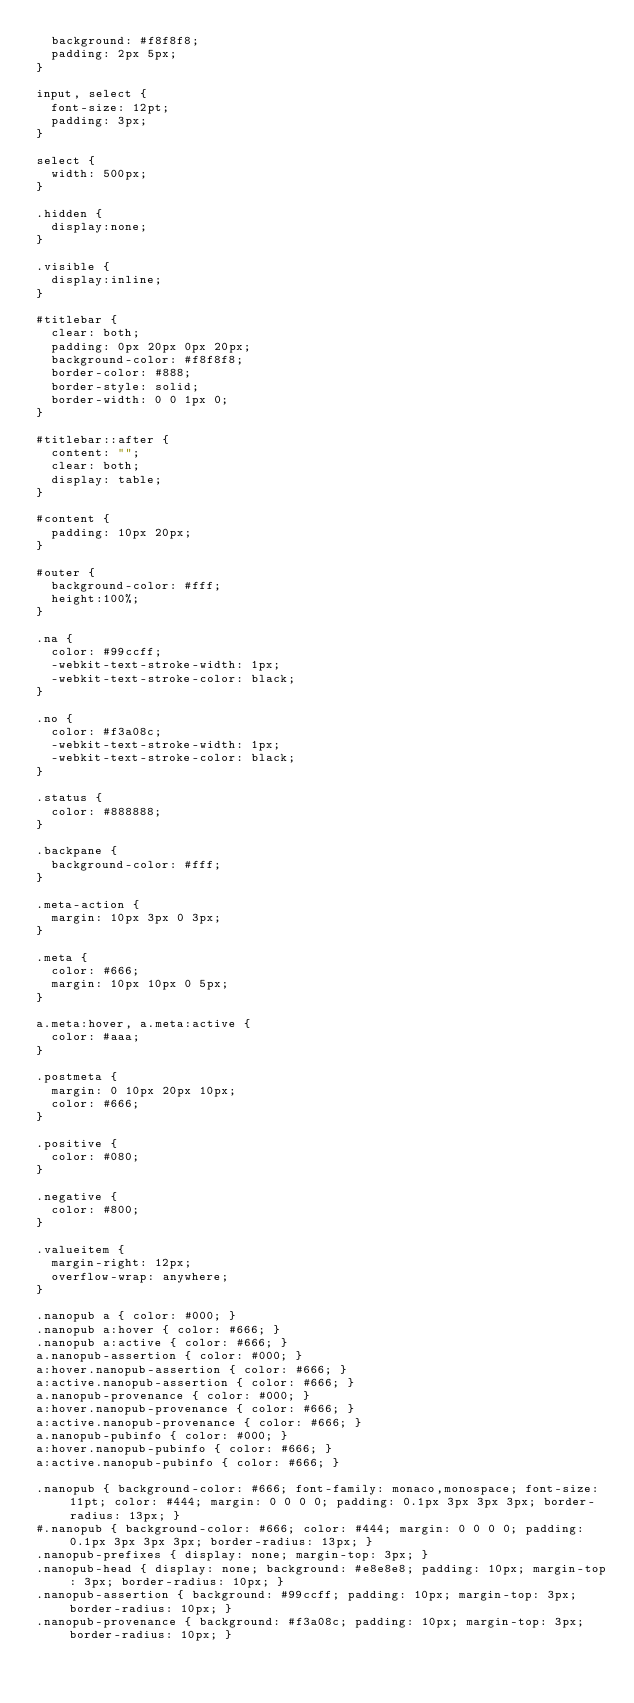<code> <loc_0><loc_0><loc_500><loc_500><_CSS_>  background: #f8f8f8;
  padding: 2px 5px;
}

input, select {
  font-size: 12pt;
  padding: 3px;
}

select {
  width: 500px;
}

.hidden {
	display:none;
}

.visible {
	display:inline;
}

#titlebar {
	clear: both;
	padding: 0px 20px 0px 20px;
	background-color: #f8f8f8;
	border-color: #888;
	border-style: solid;
	border-width: 0 0 1px 0;
}

#titlebar::after {
  content: "";
  clear: both;
  display: table;
}

#content {
	padding: 10px 20px;
}

#outer {
	background-color: #fff;
	height:100%;
}

.na {
  color: #99ccff;
  -webkit-text-stroke-width: 1px;
  -webkit-text-stroke-color: black;
}

.no {
  color: #f3a08c;
  -webkit-text-stroke-width: 1px;
  -webkit-text-stroke-color: black;
}

.status {
  color: #888888;
}

.backpane {
	background-color: #fff;
}

.meta-action {
	margin: 10px 3px 0 3px;
}

.meta {
	color: #666;
	margin: 10px 10px 0 5px;
}

a.meta:hover, a.meta:active {
	color: #aaa;
}

.postmeta {
	margin: 0 10px 20px 10px;
	color: #666;
}

.positive {
	color: #080;
}

.negative {
	color: #800;
}

.valueitem {
	margin-right: 12px;
	overflow-wrap: anywhere;
}

.nanopub a { color: #000; }
.nanopub a:hover { color: #666; }
.nanopub a:active { color: #666; }
a.nanopub-assertion { color: #000; }
a:hover.nanopub-assertion { color: #666; }
a:active.nanopub-assertion { color: #666; }
a.nanopub-provenance { color: #000; }
a:hover.nanopub-provenance { color: #666; }
a:active.nanopub-provenance { color: #666; }
a.nanopub-pubinfo { color: #000; }
a:hover.nanopub-pubinfo { color: #666; }
a:active.nanopub-pubinfo { color: #666; }

.nanopub { background-color: #666; font-family: monaco,monospace; font-size: 11pt; color: #444; margin: 0 0 0 0; padding: 0.1px 3px 3px 3px; border-radius: 13px; }
#.nanopub { background-color: #666; color: #444; margin: 0 0 0 0; padding: 0.1px 3px 3px 3px; border-radius: 13px; }
.nanopub-prefixes { display: none; margin-top: 3px; }
.nanopub-head { display: none; background: #e8e8e8; padding: 10px; margin-top: 3px; border-radius: 10px; }
.nanopub-assertion { background: #99ccff; padding: 10px; margin-top: 3px; border-radius: 10px; }
.nanopub-provenance { background: #f3a08c; padding: 10px; margin-top: 3px; border-radius: 10px; }</code> 